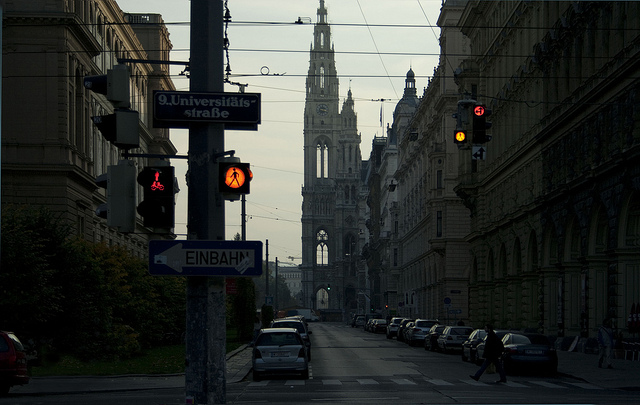<image>What time is the clock in the background? It is unknown what time is the clock in the background. What time is the clock in the background? The time on the clock in the background is unknown. 